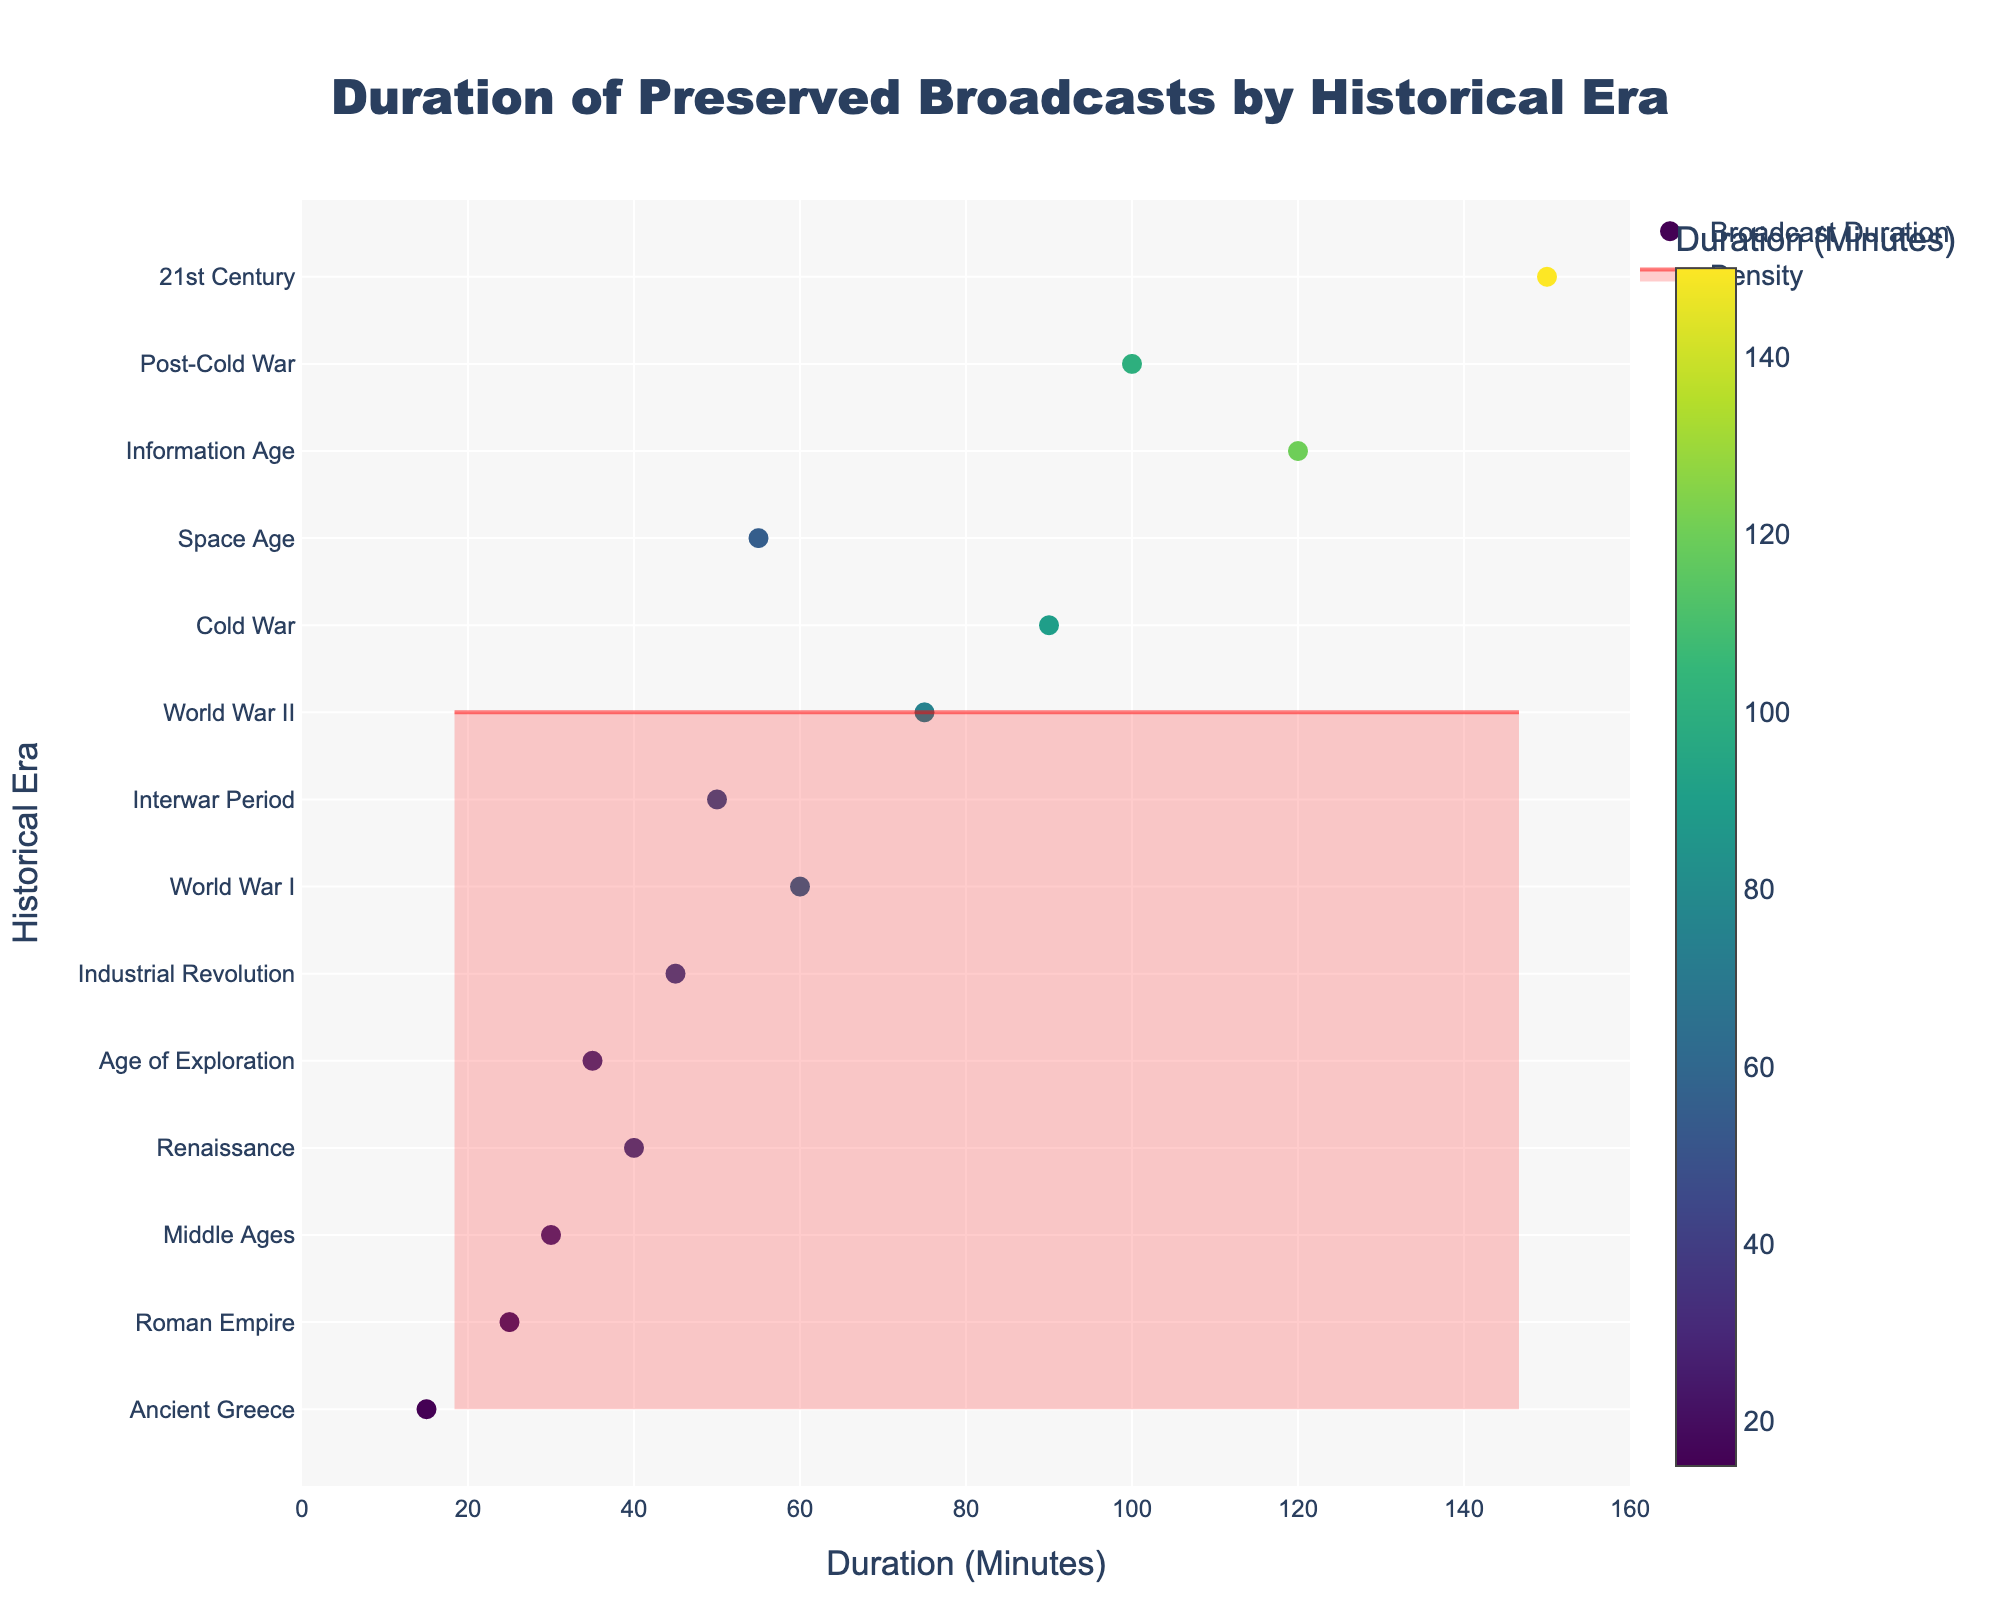What is the title of the plot? The title is usually found at the top of the plot and serves as a summary of what the plot is about.
Answer: Duration of Preserved Broadcasts by Historical Era What is the range of the x-axis in the plot? The x-axis range can be observed as the span of possible values shown along the horizontal line at the bottom of the plot.
Answer: 0 to 160 minutes How many historical eras are represented in the plot? You can count the distinct categories marked on the y-axis to determine the number of historical eras.
Answer: 14 Which historical era has the longest duration of preserved broadcasts? By looking at the markers on the rightmost side of the plot, we can identify which era points furthest to the right.
Answer: 21st Century What color scale is used to represent the duration of broadcasts? The color of the markers changes according to a color scale visible on the plot.
Answer: Viridis What is the duration of preserved broadcasts for the Cold War era? Check the marker corresponding to the "Cold War" era and the value on the x-axis.
Answer: 90 minutes Which historical era has preserved broadcasts lasting 60 minutes? Locate the marker around 60 minutes on the x-axis and find the corresponding historical era on the y-axis.
Answer: World War I What is the median duration of the preserved broadcasts across all eras? Arrange the durations in ascending order and find the middle value or average the two middle values since we have an even number of data points.
Answer: 55 minutes What is the difference in the duration of preserved broadcasts between World War II and the Post-Cold War eras? Subtract the duration value of World War II from the duration value of the Post-Cold War era (75 minutes − 100 minutes).
Answer: 25 minutes Which historical era is associated with a more densely populated duration range around 50-60 minutes? Observe the density plot (KDE) region where the filled red curve and the markers are most prominent around the 50-60 minutes mark.
Answer: Interwar Period and Space Age 